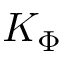<formula> <loc_0><loc_0><loc_500><loc_500>K _ { \Phi }</formula> 